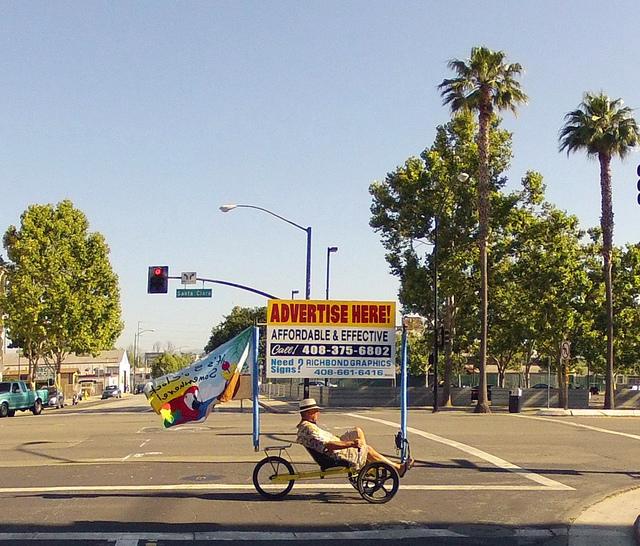What is the man riding?
Keep it brief. Bike. What is the sign attached to?
Answer briefly. Bike. What does the sign say?
Keep it brief. Advertise here. 